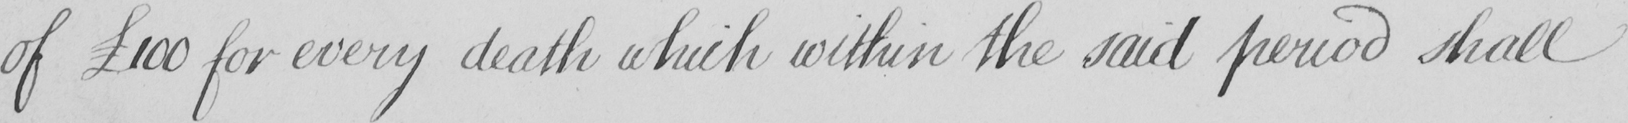Can you read and transcribe this handwriting? of  £100 for every death which within the said period shall 